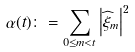Convert formula to latex. <formula><loc_0><loc_0><loc_500><loc_500>\alpha ( t ) \colon = \sum _ { 0 \leq m < t } \left | \widehat { \xi } _ { m } \right | ^ { 2 }</formula> 